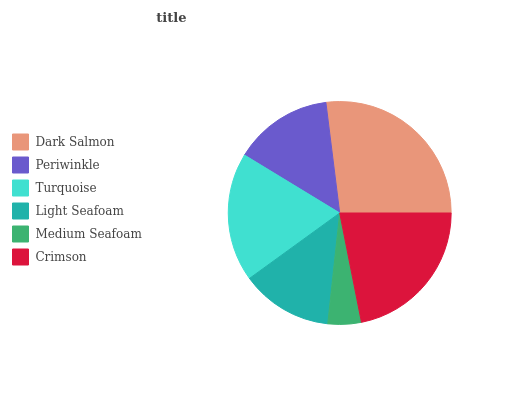Is Medium Seafoam the minimum?
Answer yes or no. Yes. Is Dark Salmon the maximum?
Answer yes or no. Yes. Is Periwinkle the minimum?
Answer yes or no. No. Is Periwinkle the maximum?
Answer yes or no. No. Is Dark Salmon greater than Periwinkle?
Answer yes or no. Yes. Is Periwinkle less than Dark Salmon?
Answer yes or no. Yes. Is Periwinkle greater than Dark Salmon?
Answer yes or no. No. Is Dark Salmon less than Periwinkle?
Answer yes or no. No. Is Turquoise the high median?
Answer yes or no. Yes. Is Periwinkle the low median?
Answer yes or no. Yes. Is Dark Salmon the high median?
Answer yes or no. No. Is Crimson the low median?
Answer yes or no. No. 